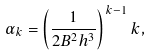<formula> <loc_0><loc_0><loc_500><loc_500>\alpha _ { k } = \left ( \frac { 1 } { 2 B ^ { 2 } h ^ { 3 } } \right ) ^ { k - 1 } k ,</formula> 